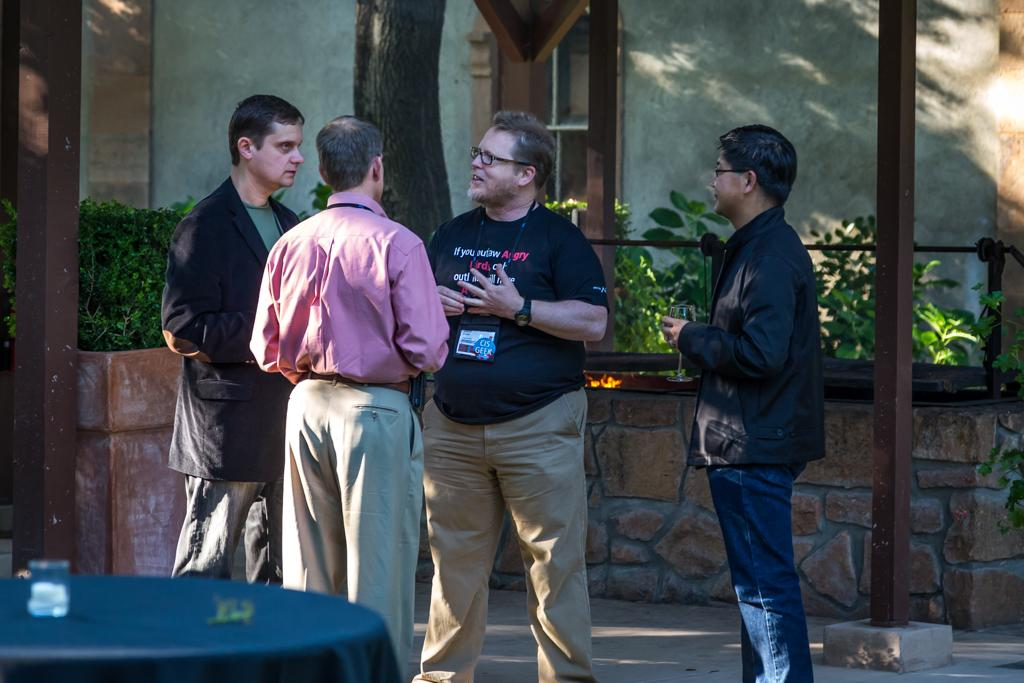How many people are in the image? There are four people in the image. What are the people doing in the image? The people are standing and discussing. What is in front of the people? There is a table in front of the people. What is on the table? There is an object on the table. What can be seen behind the people? There are plants visible behind the people. What type of flock can be seen flying over the people in the image? There is no flock visible in the image; it only shows four people standing and discussing, a table, an object on the table, and plants behind them. 